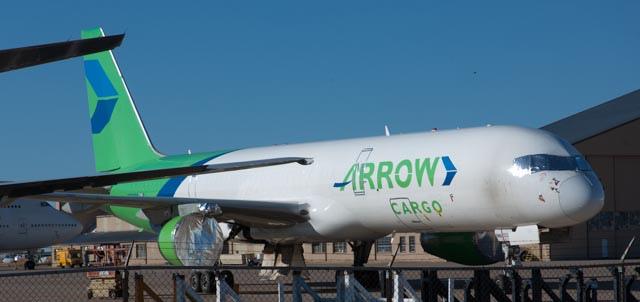How many planes are there?
Give a very brief answer. 2. What number is on the fence?
Give a very brief answer. 0. What color is the plane?
Give a very brief answer. White, green. Is this a cargo plane?
Give a very brief answer. Yes. What is the name of the plane?
Quick response, please. Arrow. Does it look cloudy?
Write a very short answer. No. Is this a 747?
Keep it brief. No. What kind of design is on the tail?
Keep it brief. Arrow. 